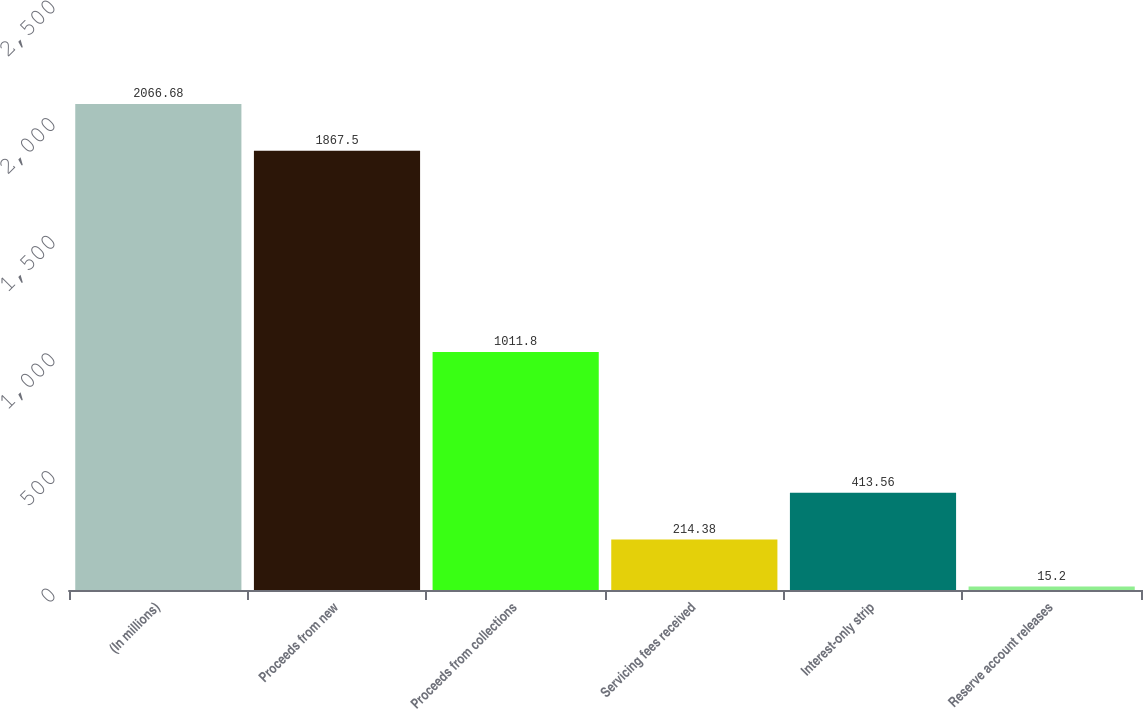Convert chart. <chart><loc_0><loc_0><loc_500><loc_500><bar_chart><fcel>(In millions)<fcel>Proceeds from new<fcel>Proceeds from collections<fcel>Servicing fees received<fcel>Interest-only strip<fcel>Reserve account releases<nl><fcel>2066.68<fcel>1867.5<fcel>1011.8<fcel>214.38<fcel>413.56<fcel>15.2<nl></chart> 